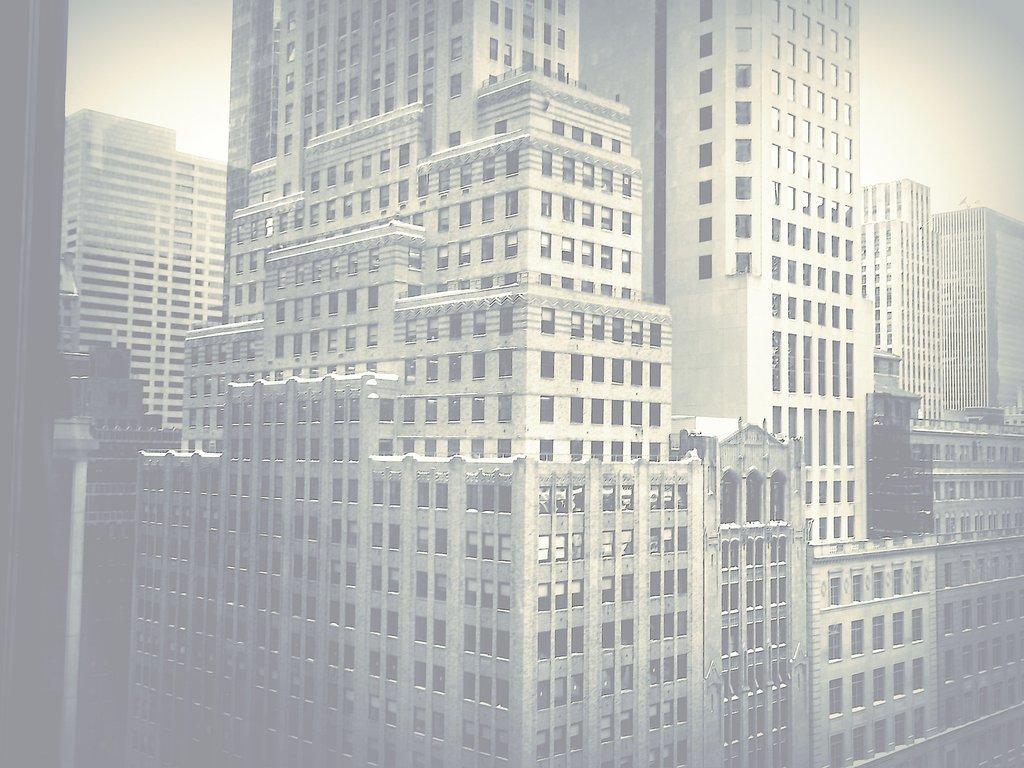Describe this image in one or two sentences. In this picture there are buildings in the center of the image. 